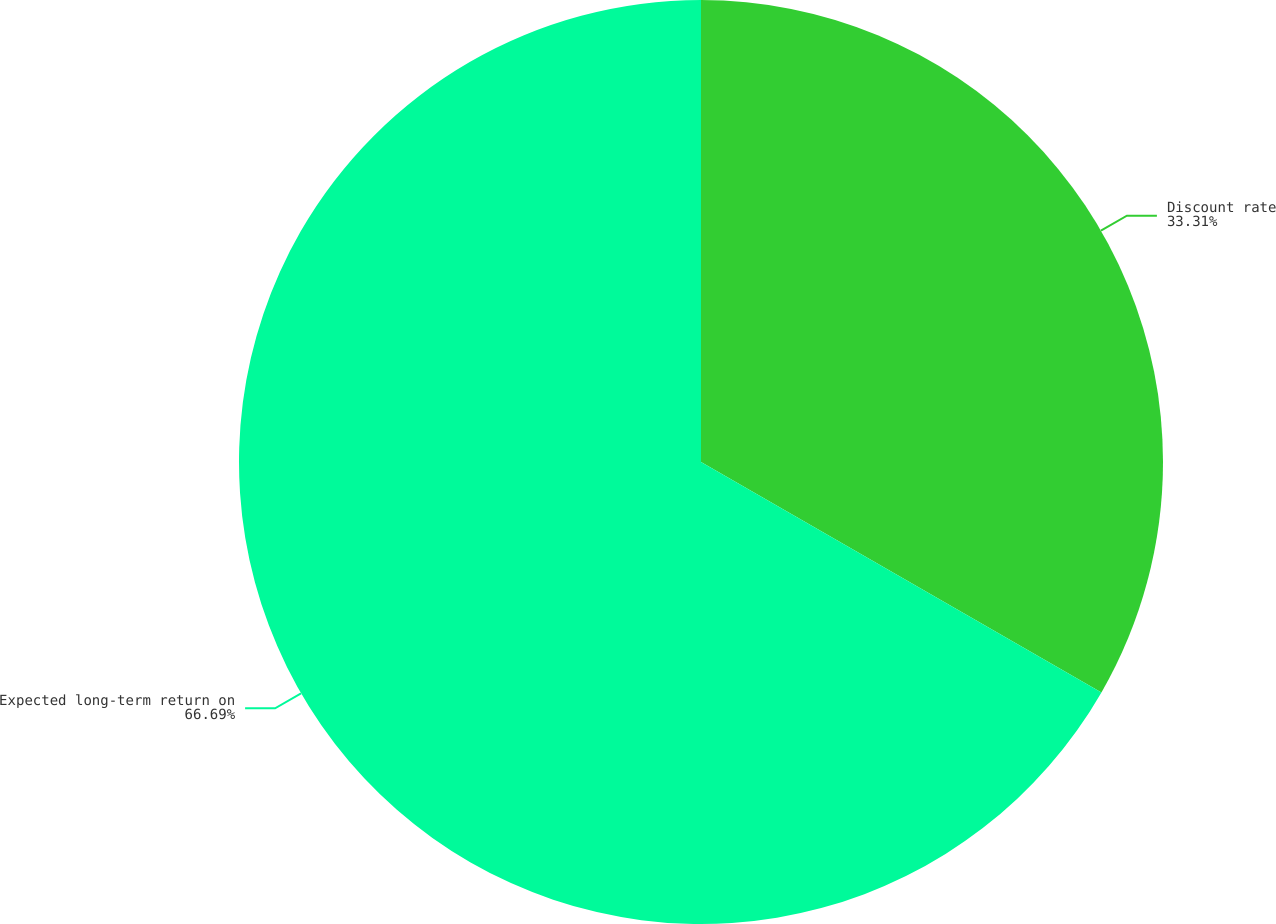<chart> <loc_0><loc_0><loc_500><loc_500><pie_chart><fcel>Discount rate<fcel>Expected long-term return on<nl><fcel>33.31%<fcel>66.69%<nl></chart> 